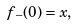<formula> <loc_0><loc_0><loc_500><loc_500>f _ { - } ( 0 ) = x ,</formula> 